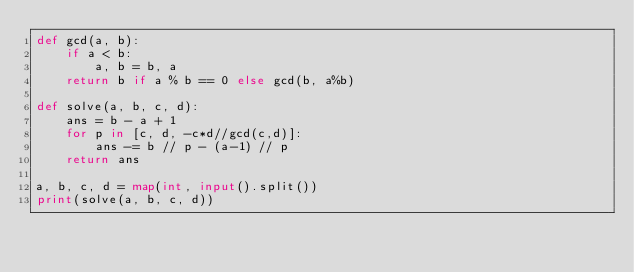<code> <loc_0><loc_0><loc_500><loc_500><_Python_>def gcd(a, b):
    if a < b:
        a, b = b, a
    return b if a % b == 0 else gcd(b, a%b)

def solve(a, b, c, d):
    ans = b - a + 1
    for p in [c, d, -c*d//gcd(c,d)]:
        ans -= b // p - (a-1) // p
    return ans

a, b, c, d = map(int, input().split())
print(solve(a, b, c, d))</code> 